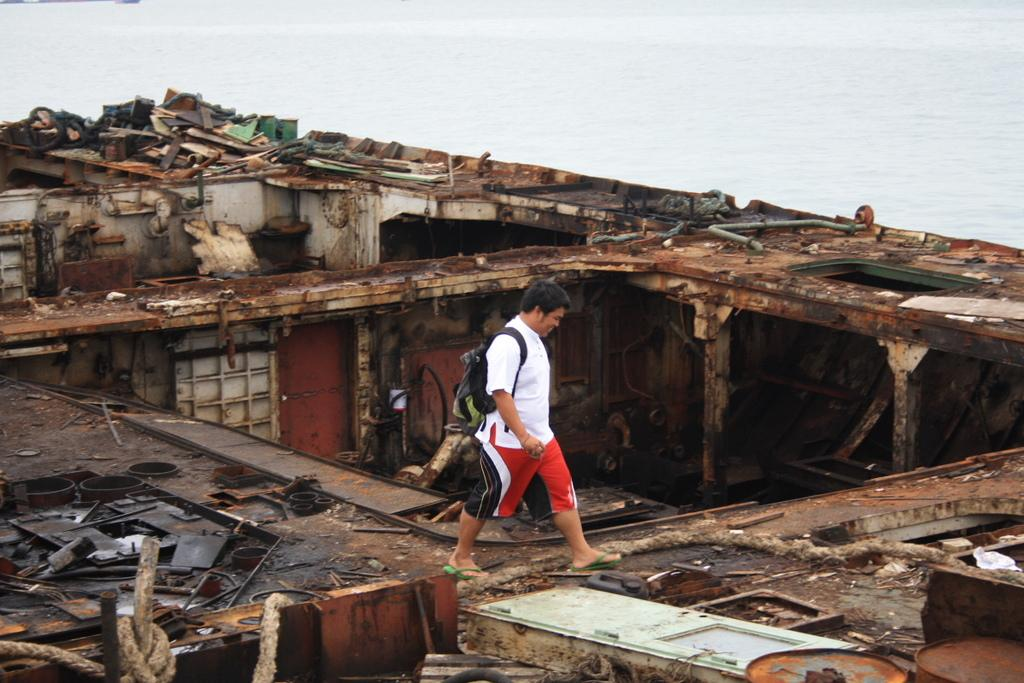What is the main subject of the image? There is a person in the image. What is the person wearing? The person is wearing a dress. What is the person carrying? The person is carrying a bag. What is the person doing in the image? The person is walking. What can be seen in the background of the image? There is a huge damaged ship in the image, and the sky is visible. What is the color of the damaged ship? The ship is brown in color. How many geese are flying over the damaged ship in the image? There are no geese present in the image; it only features a person walking and a damaged ship. What type of plane can be seen flying near the person in the image? There are no planes visible in the image; the image only shows a person walking and a damaged ship. 